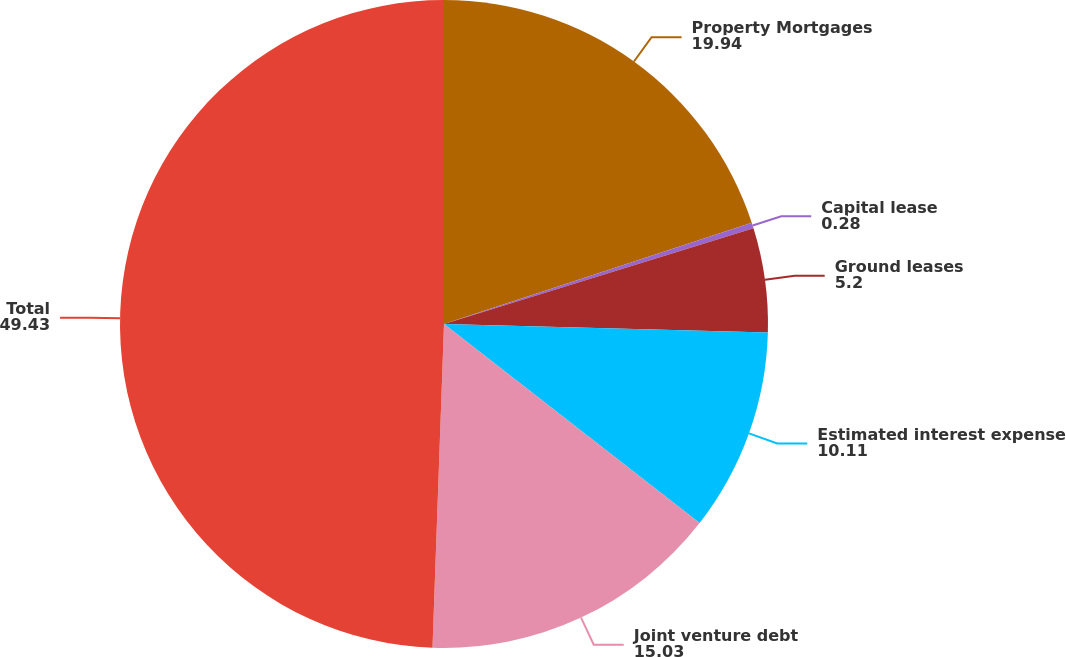Convert chart to OTSL. <chart><loc_0><loc_0><loc_500><loc_500><pie_chart><fcel>Property Mortgages<fcel>Capital lease<fcel>Ground leases<fcel>Estimated interest expense<fcel>Joint venture debt<fcel>Total<nl><fcel>19.94%<fcel>0.28%<fcel>5.2%<fcel>10.11%<fcel>15.03%<fcel>49.43%<nl></chart> 